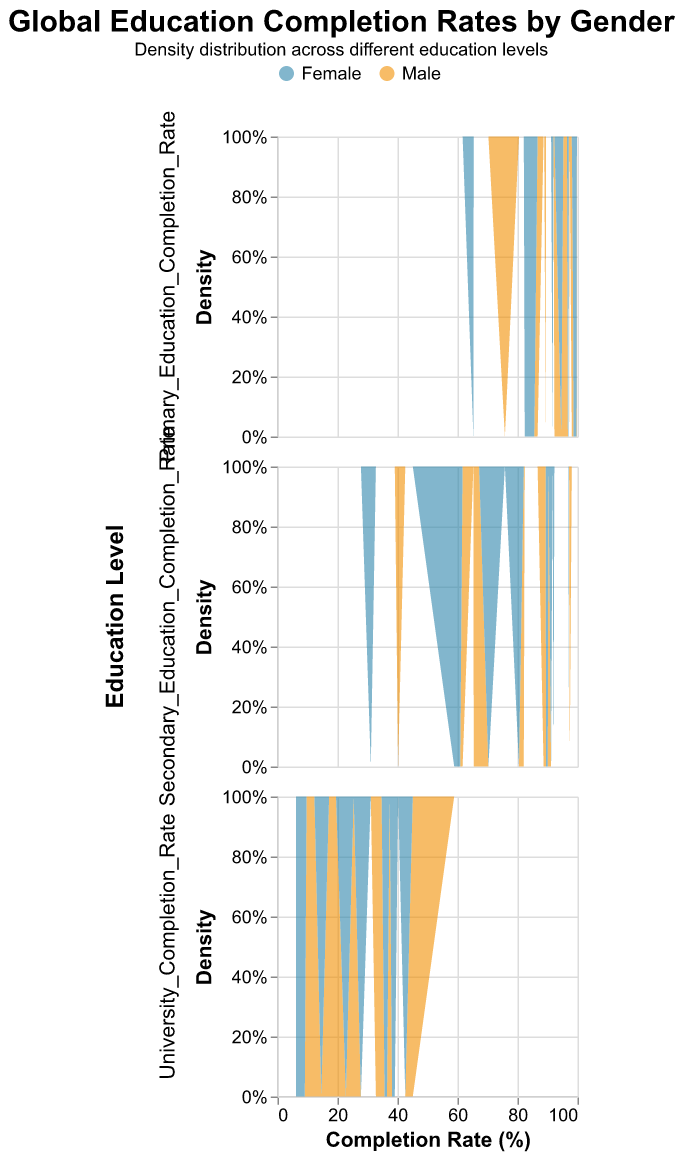What is the title of the figure? The title is typically at the top of the plot and provides a summary of the data visualization. Here, it says "Global Education Completion Rates by Gender."
Answer: Global Education Completion Rates by Gender What is the horizontal axis representing? The horizontal axis usually has a label that indicates what it represents. In this plot, the label "Completion Rate (%)" tells us that it is showing the completion rates of different education levels.
Answer: Completion Rate (%) Which country has the highest university completion rate for females? To find this, look at the distribution in the "University Completion Rate" density plot for the female category. The peak around where the highest value occurs will indicate the country. Germany and the United Kingdom have high values, but Germany is slightly higher with 38.2%.
Answer: Germany How does India's primary education completion rate for males compare to females? Examine the "Primary Education Completion Rate" density plot for India. The male completion rate is 86.7%, and the female rate is 82.4%, so males have a higher completion rate.
Answer: Males have higher completion rates than females Which education level shows the largest gender disparity for Nigeria? Look at the three density plots for Nigeria. The largest gap between males and females is in the "Secondary Education Completion Rate," where males have 40.2% and females have 31.1%. The difference is 9.1%.
Answer: Secondary Education Completion Rate What is the difference in the university completion rate between males and females in the United States? For the United States, find the distribution for both genders in the "University Completion Rate" subplot. Males have a 33.1% completion rate, and females have a 35.7% completion rate. The difference is 35.7 - 33.1.
Answer: 2.6% How do Canadian males and females compare in secondary education completion rates? Check the density distribution in the "Secondary Education Completion Rate" plot for Canadian males and females. Canadian males have a completion rate of 90.3%, and females have 91.2%.
Answer: Females have a slightly higher rate than males Which country has the highest primary education completion rate regardless of gender? Identify the highest peaks in the "Primary Education Completion Rate" density plot for both genders together. Japan has the highest primary education completion rate with values of 99.8% for males and 99.7% for females.
Answer: Japan Does any country show a higher university completion rate for males than for females? Compare the male and female density distributions in the "University Completion Rate" subplot for each country. In all countries shown, females have equal or higher completion rates than males.
Answer: No What is the average university completion rate for females across all countries? Find the university completion rates for females in all countries listed and calculate their average. The values are: 35.7, 36.5, 38.2, 9.1, 27.8, 42.6, 22.8, 6.2, 14.6, and 39.1. Summing these up gives 272.6. Dividing by the number of countries (10) gives 272.6/10.
Answer: 27.26 